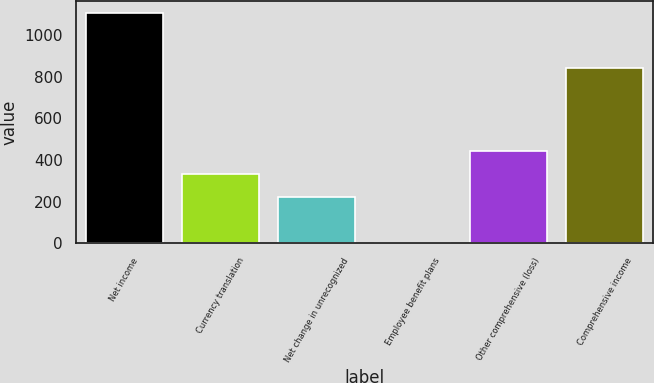<chart> <loc_0><loc_0><loc_500><loc_500><bar_chart><fcel>Net income<fcel>Currency translation<fcel>Net change in unrecognized<fcel>Employee benefit plans<fcel>Other comprehensive (loss)<fcel>Comprehensive income<nl><fcel>1107<fcel>333.5<fcel>223<fcel>2<fcel>444<fcel>844<nl></chart> 